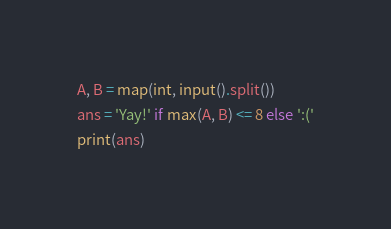Convert code to text. <code><loc_0><loc_0><loc_500><loc_500><_Python_>A, B = map(int, input().split())
ans = 'Yay!' if max(A, B) <= 8 else ':('
print(ans)
</code> 